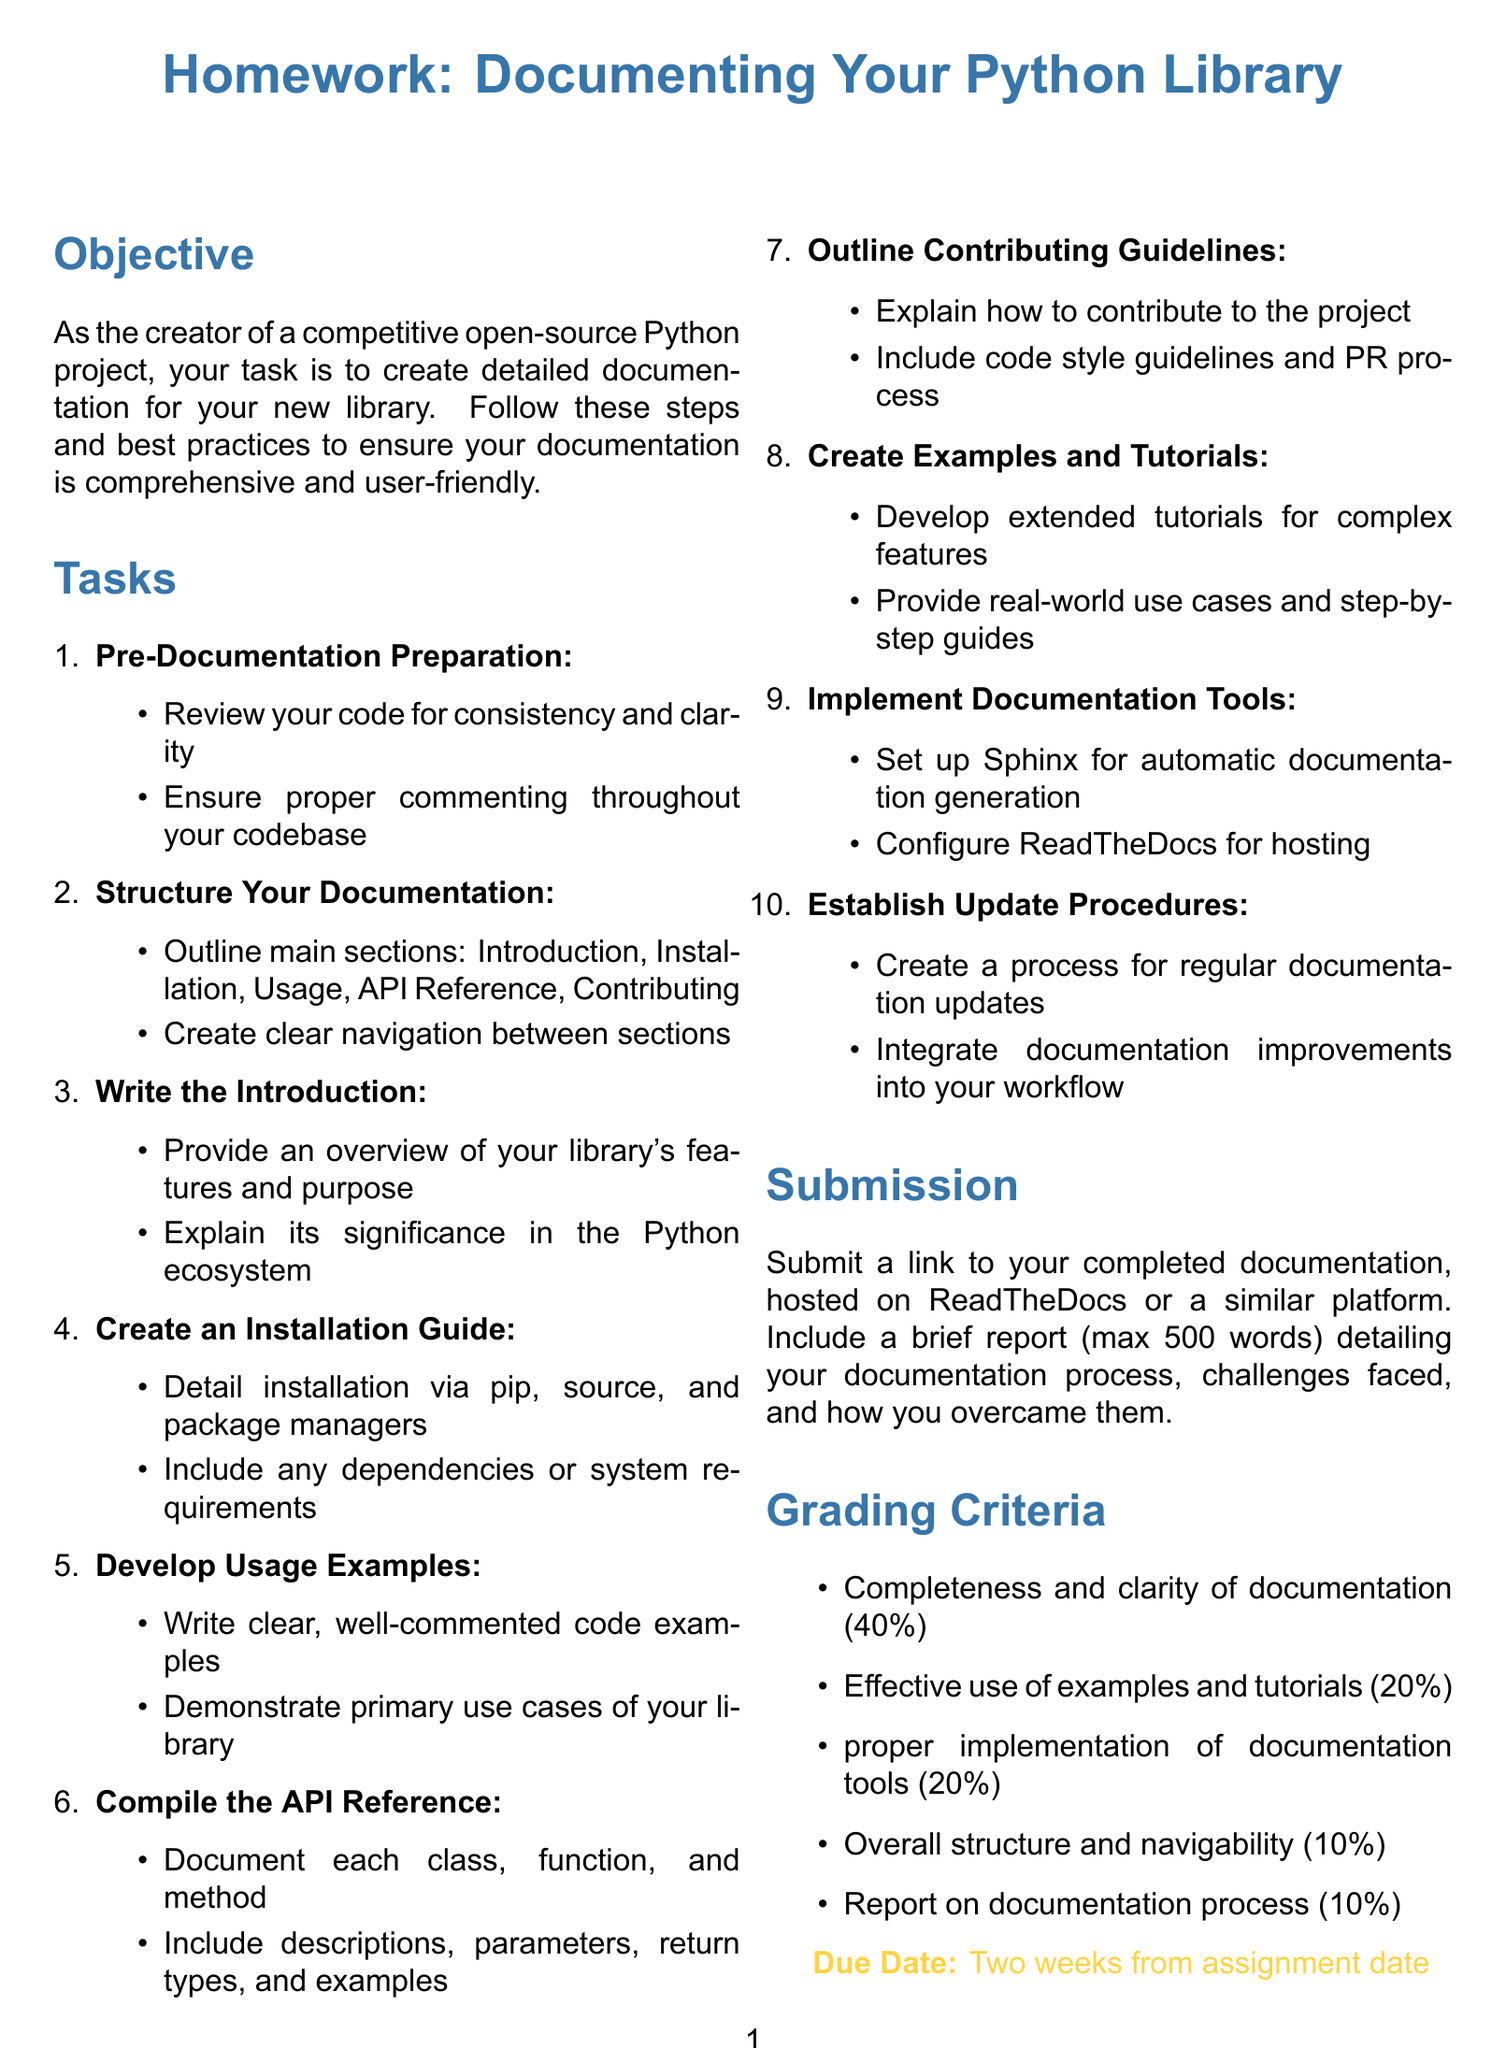What is the document's main title? The title of the document is provided in the title section and emphasizes the purpose, which is homework related to documentation.
Answer: Homework: Documenting Your Python Library What percentage of the grade is allocated to completeness and clarity of documentation? This information is specifically mentioned in the grading criteria section of the document.
Answer: 40% How many main sections should be outlined in the documentation? The number is stated in the task to structure your documentation, which specifies the main sections to include.
Answer: Five What is the maximum word limit for the report on the documentation process? The report limit is explicitly mentioned under the submission instructions.
Answer: 500 words What tool should be set up for automatic documentation generation? This is mentioned in the task to implement documentation tools, naming a specific tool used in the process.
Answer: Sphinx What is the due date format specified in the document? The due date is indicated explicitly at the bottom of the document, outlining the timeframe for submission.
Answer: Two weeks from assignment date How much is the effective use of examples and tutorials worth in grading criteria? The grading criteria section specifies the weight of this aspect in percentage form.
Answer: 20% What type of guide should be created according to the tasks? The task clearly mentions what type of guide should be developed to help users understand how to install the library.
Answer: Installation Guide How are contributions to the project to be explained? This instruction is detailed in the outline for the Contributing Guidelines within the tasks section.
Answer: Outline Contributing Guidelines 